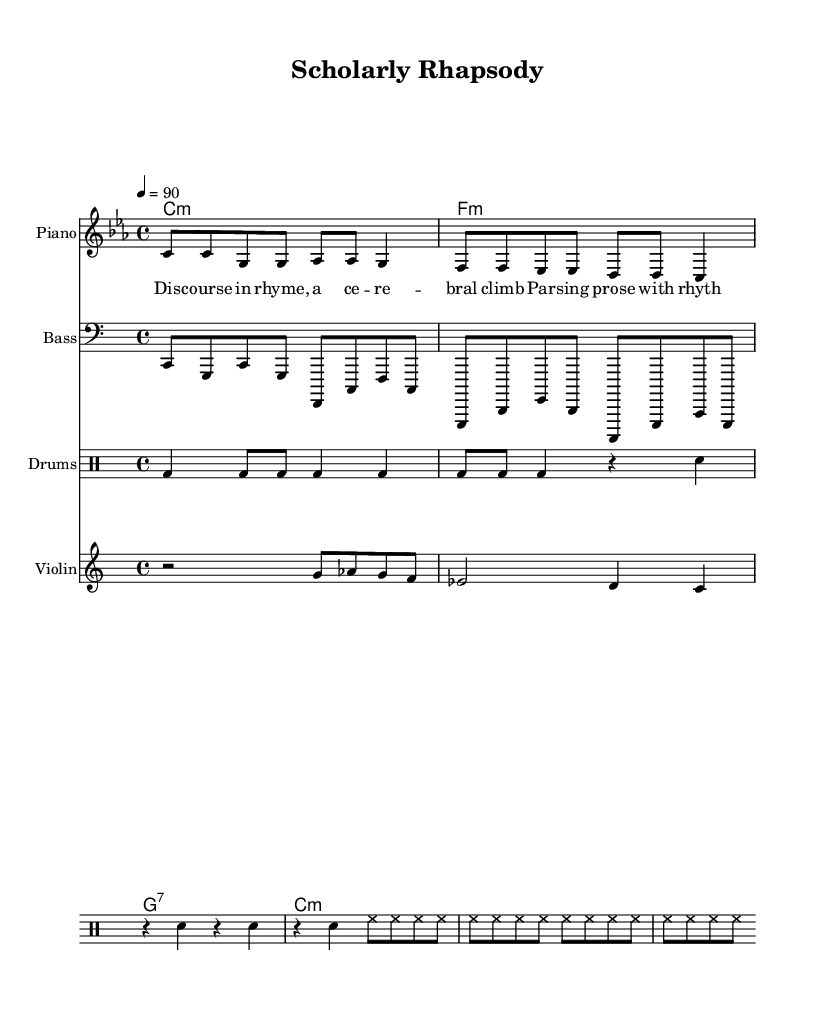What is the key signature of this music? The key signature is indicated at the beginning of the score. In this case, it shows that there is a C minor key, which typically includes three flat notes (B♭, E♭, and A♭). However, the specific indication here is C minor without any alterations, hence it remains C minor.
Answer: C minor What is the time signature of this music? The time signature is found at the start of the piece, denoted by the numbers displayed at the beginning. Here, it shows a 4/4 time signature, indicating four beats per measure with each beat represented by a quarter note.
Answer: 4/4 What is the tempo indication? The tempo is symbolized by the number with an equal sign, followed by a descriptor, which is found within the score. In this case, it is marked as 4 equals 90, which describes the beats per minute. This indicates that there are 90 beats played in one minute of music.
Answer: 90 How many measures are in the melody? To find the number of measures, we can count each distinct group of notes separated by vertical lines (bar lines) in the melody section. There are a total of 4 measures indicated here.
Answer: 4 What instruments are featured in this piece? The instruments can be identified by their respective staffs and instrument names found at the beginning of each staff. This particular piece includes piano, bass, drums, and violin.
Answer: Piano, Bass, Drums, Violin What is the thematic focus of the lyrics? The thematic focus can be discerned from the lyrics provided. The lyrics reference a discourse and rhythmic expression, which suggests an emphasis on academic themes and intellectual engagement within hip-hop.
Answer: Intellectual discourse 